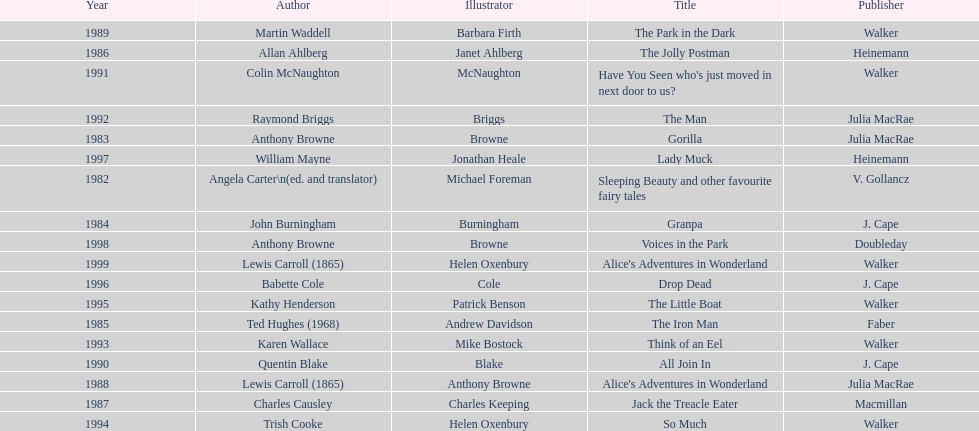Who is the author responsible for the first recognized literary work? Angela Carter. 